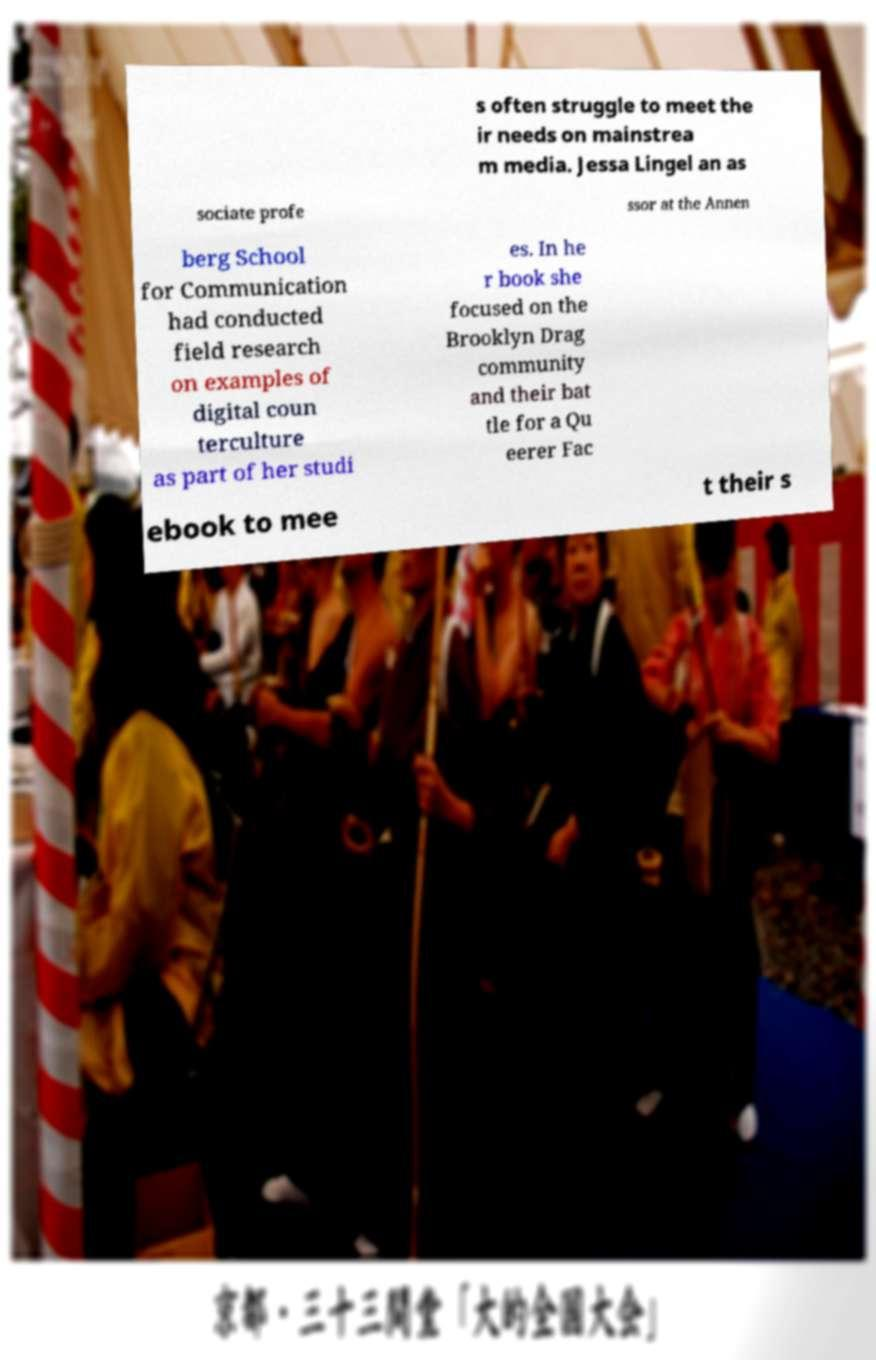What messages or text are displayed in this image? I need them in a readable, typed format. s often struggle to meet the ir needs on mainstrea m media. Jessa Lingel an as sociate profe ssor at the Annen berg School for Communication had conducted field research on examples of digital coun terculture as part of her studi es. In he r book she focused on the Brooklyn Drag community and their bat tle for a Qu eerer Fac ebook to mee t their s 